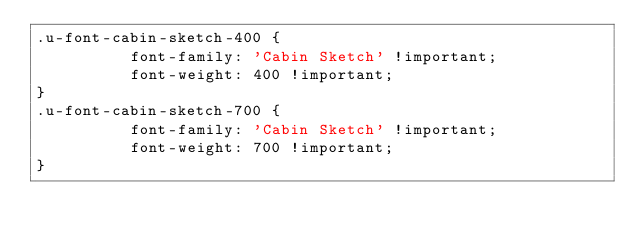Convert code to text. <code><loc_0><loc_0><loc_500><loc_500><_CSS_>.u-font-cabin-sketch-400 {
          font-family: 'Cabin Sketch' !important;
          font-weight: 400 !important;
}
.u-font-cabin-sketch-700 {
          font-family: 'Cabin Sketch' !important;
          font-weight: 700 !important;
}</code> 